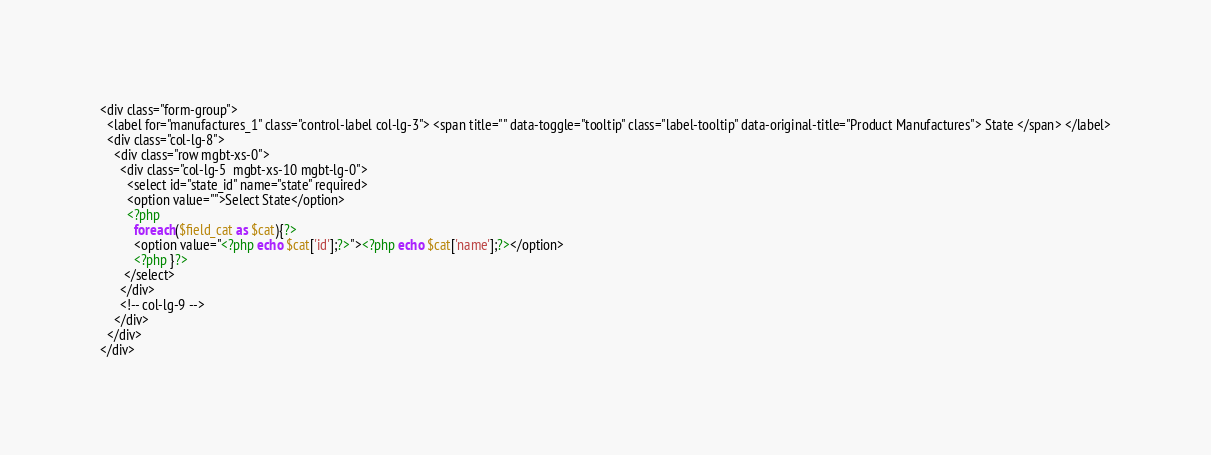<code> <loc_0><loc_0><loc_500><loc_500><_PHP_><div class="form-group">
  <label for="manufactures_1" class="control-label col-lg-3"> <span title="" data-toggle="tooltip" class="label-tooltip" data-original-title="Product Manufactures"> State </span> </label>
  <div class="col-lg-8">
    <div class="row mgbt-xs-0">
      <div class="col-lg-5  mgbt-xs-10 mgbt-lg-0">
        <select id="state_id" name="state" required>
        <option value="">Select State</option>
        <?php
          foreach($field_cat as $cat){?>
          <option value="<?php echo $cat['id'];?>"><?php echo $cat['name'];?></option>
          <?php }?>
       </select>
      </div>
      <!-- col-lg-9 --> 
    </div>
  </div>
</div></code> 